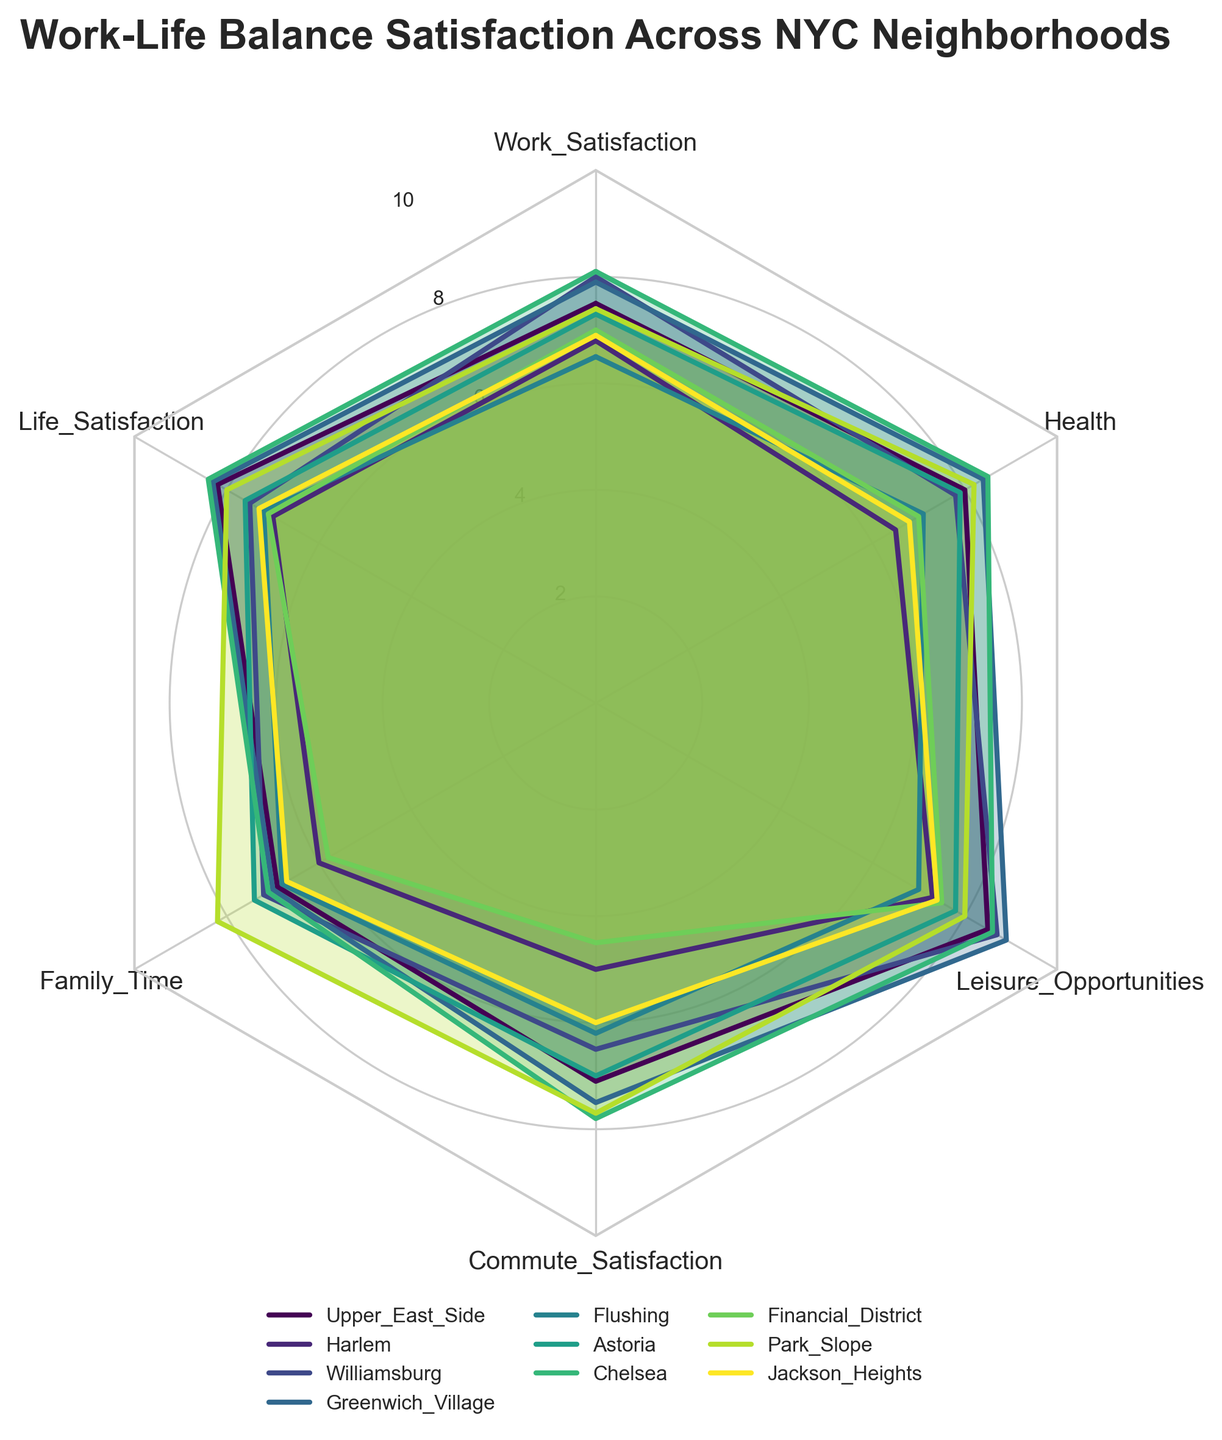Which neighborhood scored the highest in Leisure Opportunities? To determine this, we locate the axis for "Leisure Opportunities" on the radar chart and identify which neighborhood has the plot that extends the furthest along this axis. From the provided data, Greenwich Village scored the highest with a score of 8.9.
Answer: Greenwich Village What is the average Work Satisfaction score across all neighborhoods? First, extract the Work Satisfaction scores: 7.5, 6.8, 8.0, 7.9, 6.5, 7.3, 8.1, 7.0, 7.4, 6.9. Then compute the sum (7.5 + 6.8 + 8.0 + 7.9 + 6.5 + 7.3 + 8.1 + 7.0 + 7.4 + 6.9) totaling to 73.4. Finally, divide by the number of neighborhoods (10), giving an average of 7.34.
Answer: 7.34 Which neighborhood has the lowest Commute Satisfaction? To find this, look for the smallest value along the "Commute Satisfaction" axis. Review the data to see that the Financial District has the lowest score with a 4.5.
Answer: Financial District How does Williamsburg's Health score compare to Astoria's? Identify the Health scores for Williamsburg (7.8) and Astoria (7.9). Williamsburg’s Health score is slightly lower than Astoria’s.
Answer: Astoria is higher Which neighborhood has the most balanced scores across all categories? A neighborhood with balanced scores will have plots nearest to a circle, denoting similar values across all axes. Reviewing the radar chart, both Chelsea and Greenwich Village appear to have consistently high and similar scores across all categories.
Answer: Chelsea, Greenwich Village What is the difference between the highest and lowest scores in Family Time? First, identify the highest (Park Slope, 8.2) and lowest (Financial District, 5.8) scores for Family Time. Then compute the difference: 8.2 - 5.8 = 2.4.
Answer: 2.4 Compare the Life Satisfaction scores of Upper East Side and Park Slope. Check the radar chart for Life Satisfaction values: Upper East Side has an 8.2, and Park Slope has an 8.0. Upper East Side has a marginally higher score.
Answer: Upper East Side is higher Which categories have the Upper East Side and Chelsea scored equally? Compare the values for each category in the Upper East Side and Chelsea. They both score the same in Work Satisfaction (7.5) and Leisure Opportunities (8.5).
Answer: Work Satisfaction, Leisure Opportunities What is the combined average Health score of Harlem, Greenwich Village, and Flushing? Extract Health scores for Harlem (6.5), Greenwich Village (8.4), and Flushing (7.1). Sum them to get (6.5 + 8.4 + 7.1) = 22. Divide by the number of neighborhoods (3) to find the average: 22 / 3 ≈ 7.33.
Answer: 7.33 